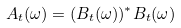<formula> <loc_0><loc_0><loc_500><loc_500>A _ { t } ( \omega ) = ( B _ { t } ( \omega ) ) ^ { * } B _ { t } ( \omega )</formula> 